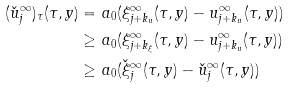Convert formula to latex. <formula><loc_0><loc_0><loc_500><loc_500>( \check { u } _ { j } ^ { \infty } ) _ { \tau } ( \tau , y ) = & \ a _ { 0 } ( \xi _ { j + k _ { u } } ^ { \infty } ( \tau , y ) - u _ { j + k _ { u } } ^ { \infty } ( \tau , y ) ) \\ \geq & \ a _ { 0 } ( \xi _ { j + k _ { \xi } } ^ { \infty } ( \tau , y ) - u _ { j + k _ { u } } ^ { \infty } ( \tau , y ) ) \\ \geq & \ a _ { 0 } ( \check { \xi } _ { j } ^ { \infty } ( \tau , y ) - \check { u } _ { j } ^ { \infty } ( \tau , y ) )</formula> 